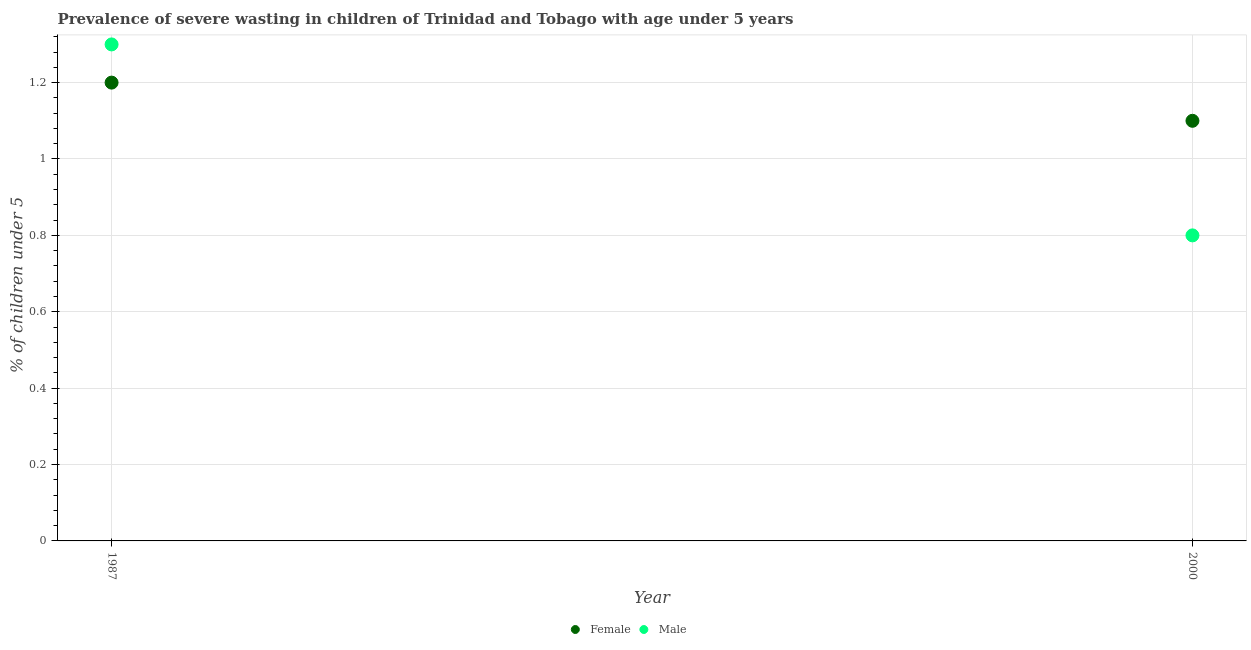What is the percentage of undernourished female children in 1987?
Your response must be concise. 1.2. Across all years, what is the maximum percentage of undernourished female children?
Provide a short and direct response. 1.2. Across all years, what is the minimum percentage of undernourished female children?
Ensure brevity in your answer.  1.1. In which year was the percentage of undernourished female children minimum?
Your answer should be very brief. 2000. What is the total percentage of undernourished female children in the graph?
Your answer should be compact. 2.3. What is the difference between the percentage of undernourished female children in 1987 and that in 2000?
Give a very brief answer. 0.1. What is the difference between the percentage of undernourished female children in 1987 and the percentage of undernourished male children in 2000?
Offer a terse response. 0.4. What is the average percentage of undernourished male children per year?
Keep it short and to the point. 1.05. In the year 1987, what is the difference between the percentage of undernourished female children and percentage of undernourished male children?
Your response must be concise. -0.1. In how many years, is the percentage of undernourished male children greater than 0.32 %?
Offer a terse response. 2. What is the ratio of the percentage of undernourished female children in 1987 to that in 2000?
Offer a very short reply. 1.09. Does the percentage of undernourished female children monotonically increase over the years?
Your response must be concise. No. Is the percentage of undernourished male children strictly greater than the percentage of undernourished female children over the years?
Your response must be concise. No. How many dotlines are there?
Make the answer very short. 2. How many years are there in the graph?
Your answer should be compact. 2. Does the graph contain any zero values?
Keep it short and to the point. No. Does the graph contain grids?
Your answer should be very brief. Yes. How are the legend labels stacked?
Provide a short and direct response. Horizontal. What is the title of the graph?
Ensure brevity in your answer.  Prevalence of severe wasting in children of Trinidad and Tobago with age under 5 years. What is the label or title of the Y-axis?
Give a very brief answer.  % of children under 5. What is the  % of children under 5 in Female in 1987?
Make the answer very short. 1.2. What is the  % of children under 5 in Male in 1987?
Give a very brief answer. 1.3. What is the  % of children under 5 in Female in 2000?
Provide a succinct answer. 1.1. What is the  % of children under 5 in Male in 2000?
Offer a terse response. 0.8. Across all years, what is the maximum  % of children under 5 of Female?
Give a very brief answer. 1.2. Across all years, what is the maximum  % of children under 5 in Male?
Offer a terse response. 1.3. Across all years, what is the minimum  % of children under 5 in Female?
Offer a very short reply. 1.1. Across all years, what is the minimum  % of children under 5 in Male?
Your response must be concise. 0.8. What is the total  % of children under 5 in Male in the graph?
Offer a very short reply. 2.1. What is the difference between the  % of children under 5 of Female in 1987 and that in 2000?
Offer a very short reply. 0.1. What is the difference between the  % of children under 5 of Male in 1987 and that in 2000?
Give a very brief answer. 0.5. What is the difference between the  % of children under 5 in Female in 1987 and the  % of children under 5 in Male in 2000?
Offer a terse response. 0.4. What is the average  % of children under 5 in Female per year?
Offer a very short reply. 1.15. In the year 2000, what is the difference between the  % of children under 5 in Female and  % of children under 5 in Male?
Your response must be concise. 0.3. What is the ratio of the  % of children under 5 of Male in 1987 to that in 2000?
Give a very brief answer. 1.62. What is the difference between the highest and the lowest  % of children under 5 in Male?
Your answer should be compact. 0.5. 